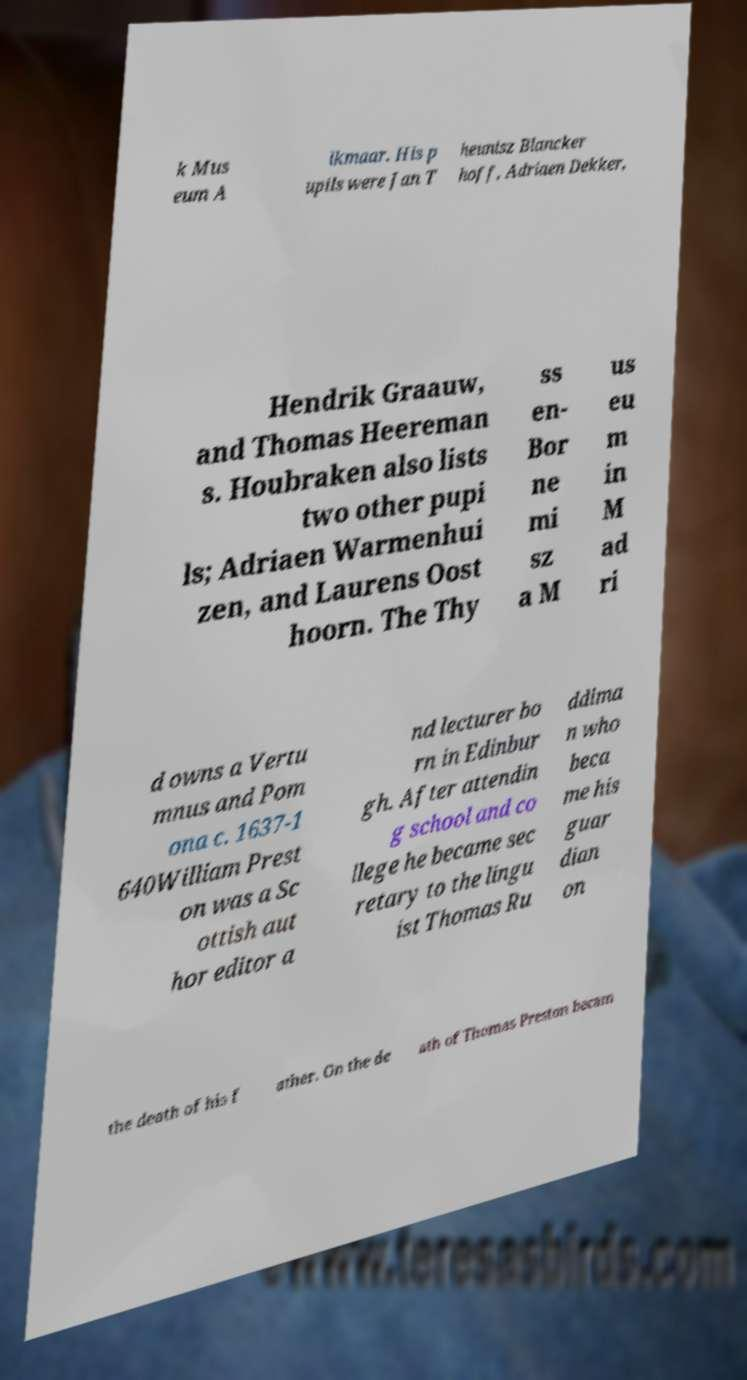Could you extract and type out the text from this image? k Mus eum A lkmaar. His p upils were Jan T heunisz Blancker hoff, Adriaen Dekker, Hendrik Graauw, and Thomas Heereman s. Houbraken also lists two other pupi ls; Adriaen Warmenhui zen, and Laurens Oost hoorn. The Thy ss en- Bor ne mi sz a M us eu m in M ad ri d owns a Vertu mnus and Pom ona c. 1637-1 640William Prest on was a Sc ottish aut hor editor a nd lecturer bo rn in Edinbur gh. After attendin g school and co llege he became sec retary to the lingu ist Thomas Ru ddima n who beca me his guar dian on the death of his f ather. On the de ath of Thomas Preston becam 